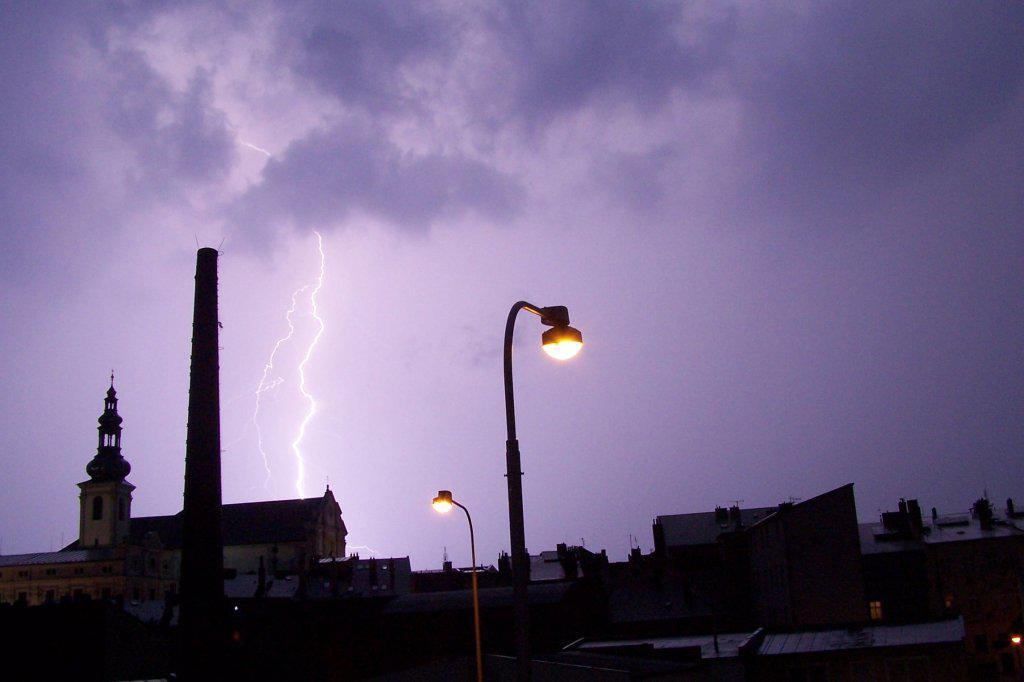What type of structures are located at the bottom of the image? There are many buildings at the bottom of the image. Are there any other objects visible at the bottom of the image? Yes, there are two street lights at the bottom of the image. What can be seen in the sky in the background of the image? There are thunders visible in the sky in the background. What type of natural formations are visible at the top of the image? There are clouds visible at the top of the image. Can you tell me how many needles are sticking out of the house in the image? There is no house present in the image, and therefore no needles can be observed. What type of belief system is depicted in the image? There is no indication of any belief system in the image. 